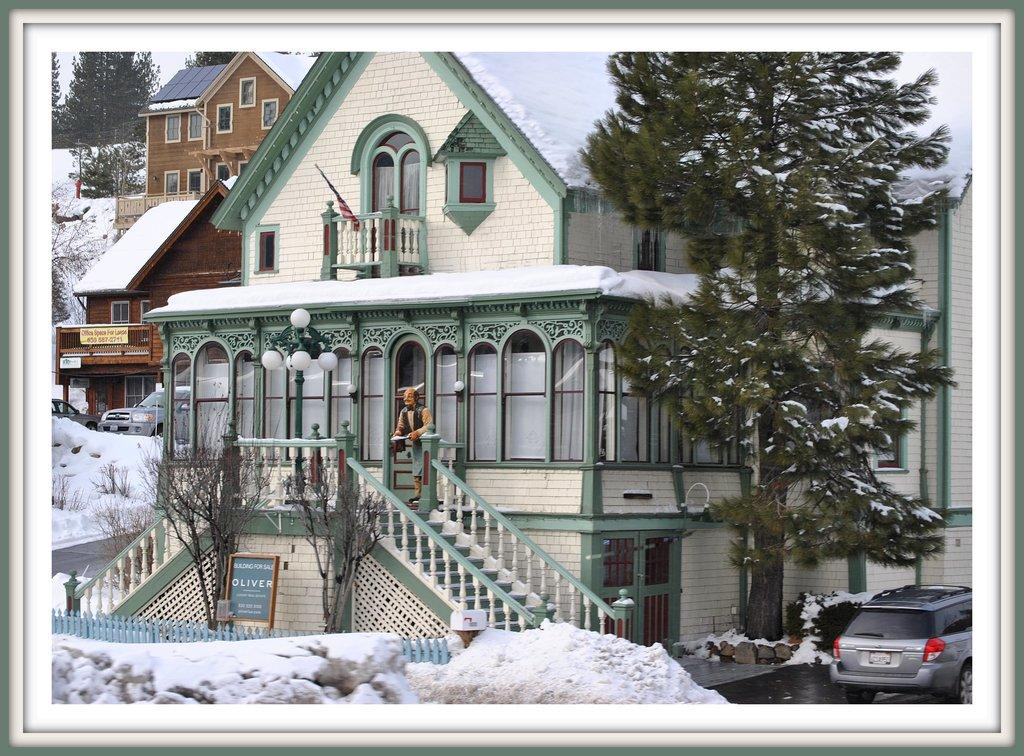What type of structures can be seen in the image? There are buildings in the image. What feature do the buildings have? The buildings have windows. What architectural element is present in the image? There are stairs in the image. What weather condition is depicted in the image? There is snow visible in the image. What type of vegetation is present in the image? There are trees in the image. What object can be seen in the image? There is a board in the image. What type of barrier is present in the image? There is fencing in the image. What mode of transportation is visible in the image? There are vehicles in the image. What type of figurine is present in the image? There is a toy person standing in the image. How does the earthquake affect the buildings in the image? There is no earthquake present in the image; the buildings appear to be standing normally. What type of shock can be seen on the toy person's face in the image? There is no indication of a shocked expression on the toy person's face in the image. 